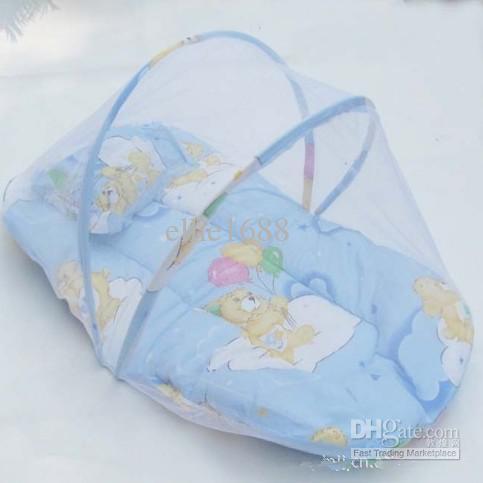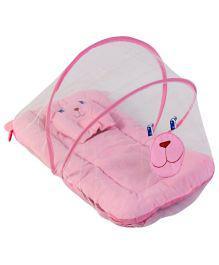The first image is the image on the left, the second image is the image on the right. Analyze the images presented: Is the assertion "One of the baby sleeper items is blue." valid? Answer yes or no. Yes. 